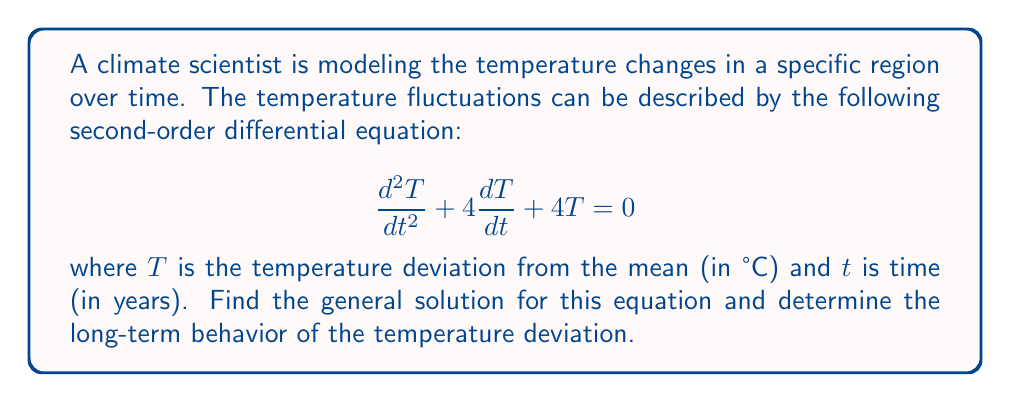What is the answer to this math problem? To solve this second-order differential equation, we follow these steps:

1) First, we identify the characteristic equation:
   $$r^2 + 4r + 4 = 0$$

2) We solve this quadratic equation:
   $$(r + 2)^2 = 0$$
   $$r = -2$$ (repeated root)

3) When we have a repeated root, the general solution takes the form:
   $$T(t) = (C_1 + C_2t)e^{-2t}$$
   where $C_1$ and $C_2$ are arbitrary constants.

4) This is our general solution. To understand the long-term behavior, we examine what happens as $t$ approaches infinity:

   $$\lim_{t \to \infty} T(t) = \lim_{t \to \infty} (C_1 + C_2t)e^{-2t} = 0$$

   This is because $e^{-2t}$ approaches 0 faster than $t$ grows.

5) The solution represents a decay towards 0, which in this context means the temperature deviation tends towards the mean temperature over time. The rate of decay is determined by the exponential term $e^{-2t}$.

6) The term $C_1 + C_2t$ allows for an initial increase in the magnitude of the deviation (if $C_2$ is nonzero), but eventually, the exponential decay dominates.
Answer: The general solution is $T(t) = (C_1 + C_2t)e^{-2t}$, where $C_1$ and $C_2$ are constants determined by initial conditions. The long-term behavior shows that the temperature deviation approaches 0 as time increases, indicating a return to the mean temperature. 